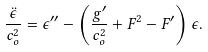<formula> <loc_0><loc_0><loc_500><loc_500>\frac { \ddot { \epsilon } } { c _ { o } ^ { 2 } } = \epsilon ^ { \prime \prime } - \left ( \frac { g ^ { \prime } } { c _ { o } ^ { 2 } } + F ^ { 2 } - F ^ { \prime } \right ) \epsilon .</formula> 